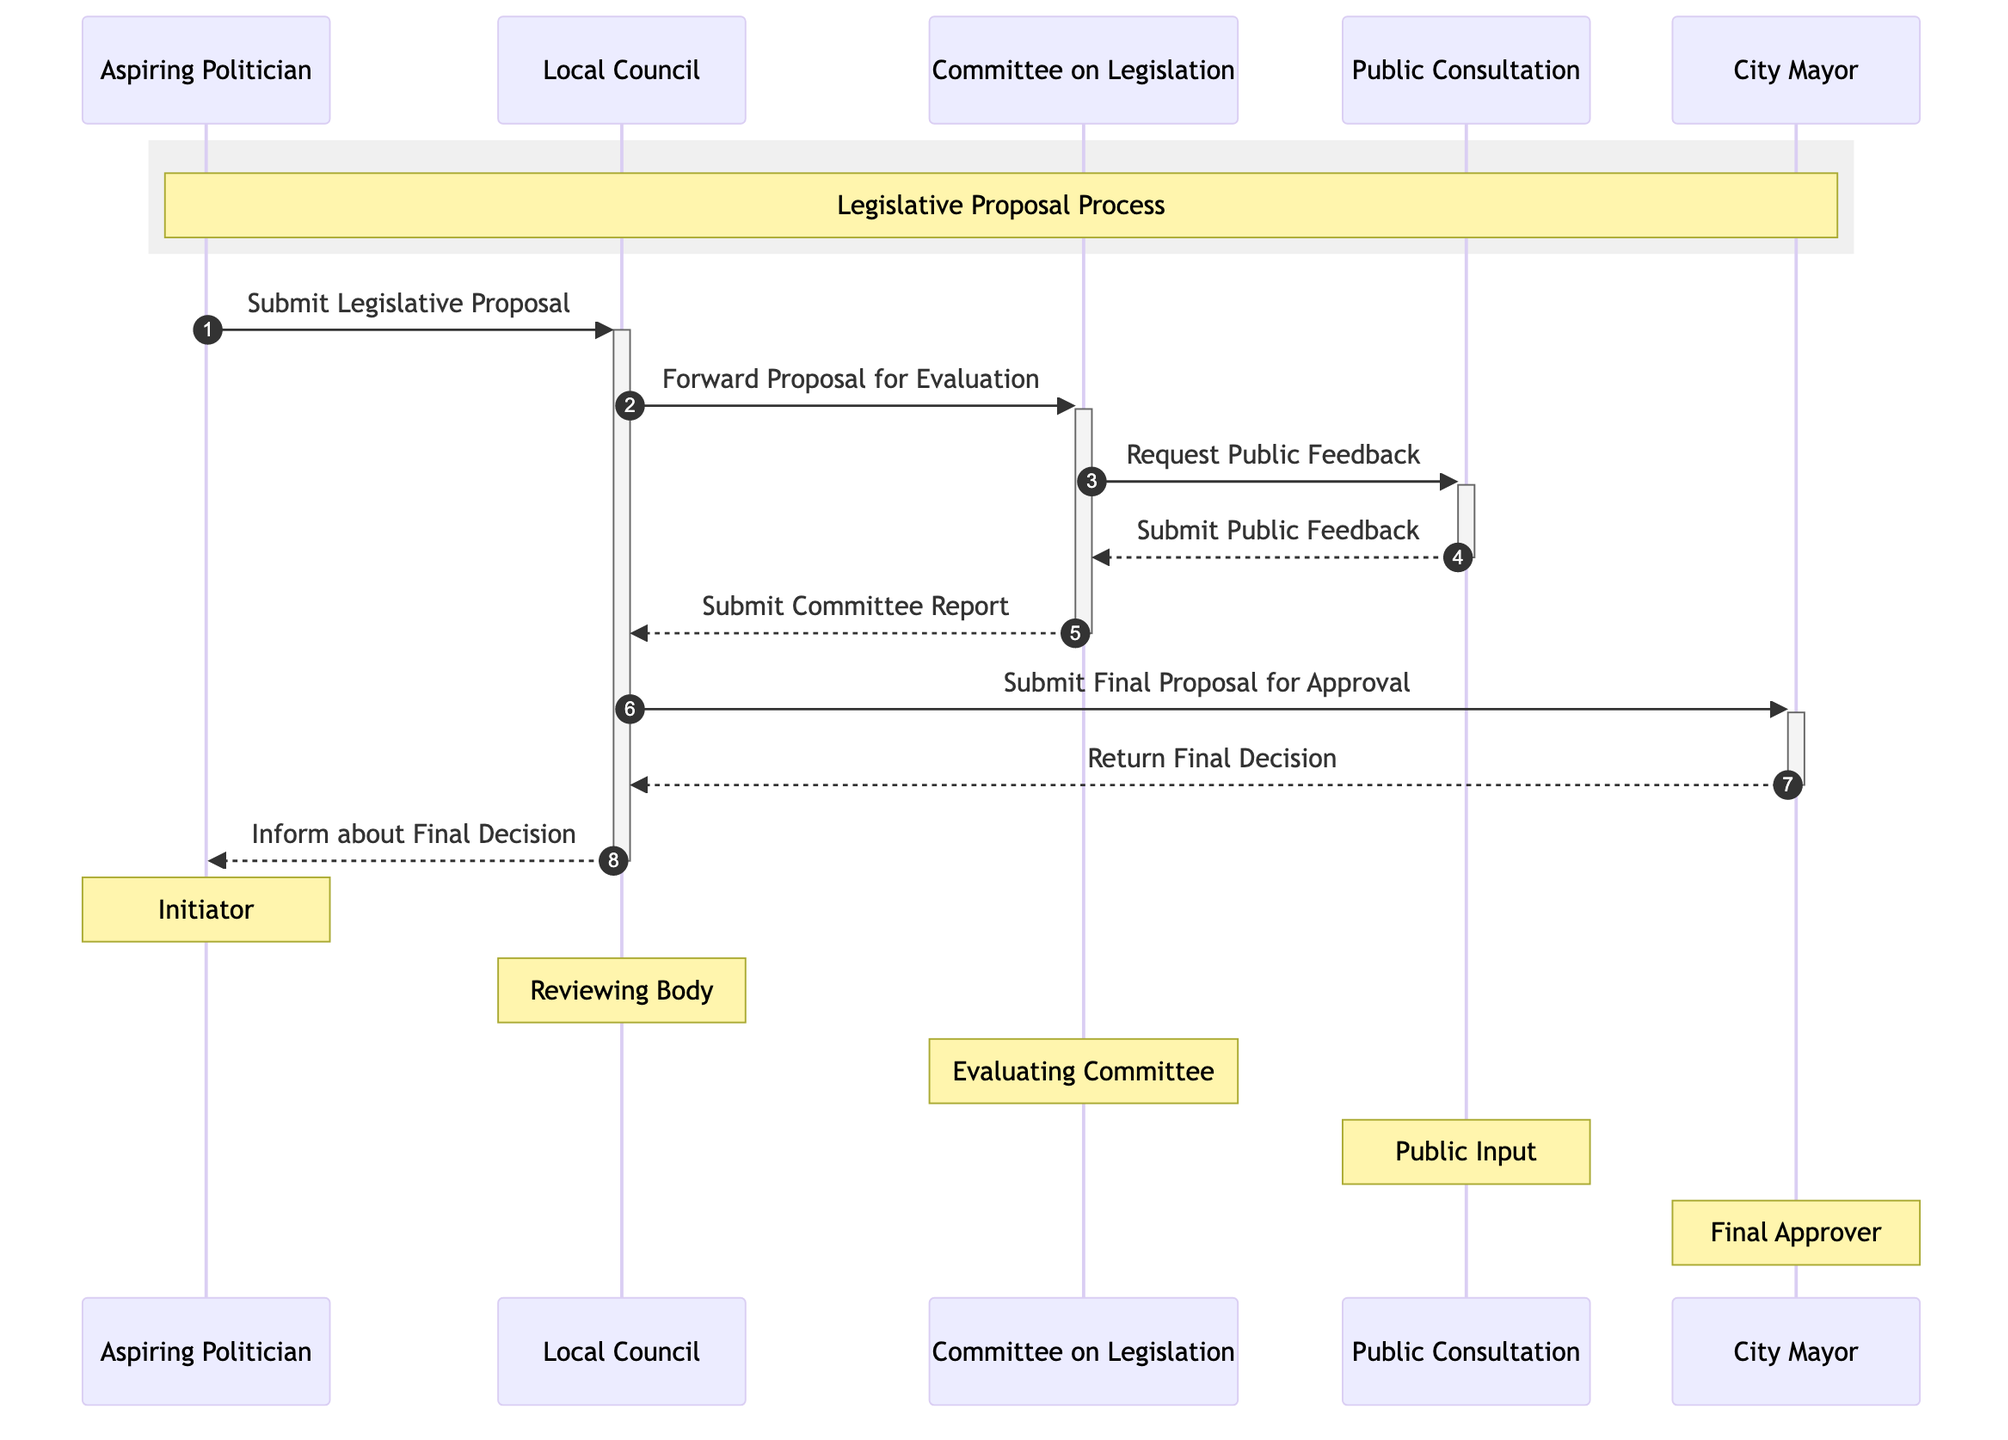What is the role of the Aspiring Politician? The Aspiring Politician is identified as the "Initiator of the Proposal" in the diagram. This role is indicated in the notes section specifically associated with this actor.
Answer: Initiator of the Proposal How many actors are involved in the Legislative Proposal Process? By counting the "actors" listed in the diagram, we find five individuals: Aspiring Politician, Local Council, Committee on Legislation, Public Consultation, and City Mayor.
Answer: Five What document does the Local Council send to the Committee on Legislation? The message indicates that the Local Council forwards the "Legislative Proposal" for evaluation, which is explicitly mentioned in the interaction line.
Answer: Legislative Proposal What feedback does the Committee on Legislation receive, and from whom? The Committee on Legislation receives "Public Feedback" from the Public Consultation, as shown in the diagram. This is illustrated in the interaction arrows and the corresponding labels.
Answer: Public Feedback What is the final output after the City Mayor reviews the proposal? The process concludes with the City Mayor returning the "Final Decision" to the Local Council, which signifies the completion of the legislative proposal evaluation.
Answer: Final Decision Which participant requests public feedback? The diagram clearly illustrates that the Committee on Legislation makes the request to the Public Consultation for feedback, as seen in the interaction line.
Answer: Committee on Legislation What happens after the Local Council receives the Committee Report? Following the receipt of the Committee Report, the Local Council submits the final proposal for approval to the City Mayor. This flow is clear from the next action described in the diagram.
Answer: Submit Final Proposal for Approval How many messages are exchanged between the actors in this sequence? By counting each line marked with interaction arrows in the diagram, a total of seven messages are exchanged between the actors in the legislative proposal process.
Answer: Seven What is the sequence of approval starting from the Local Council? The sequence begins from the Local Council submitting the final proposal to the City Mayor, which culminates with the City Mayor returning the final decision to the Local Council. This stepwise action leads to the final outcome of the process.
Answer: Submit Final Proposal for Approval, Return Final Decision 